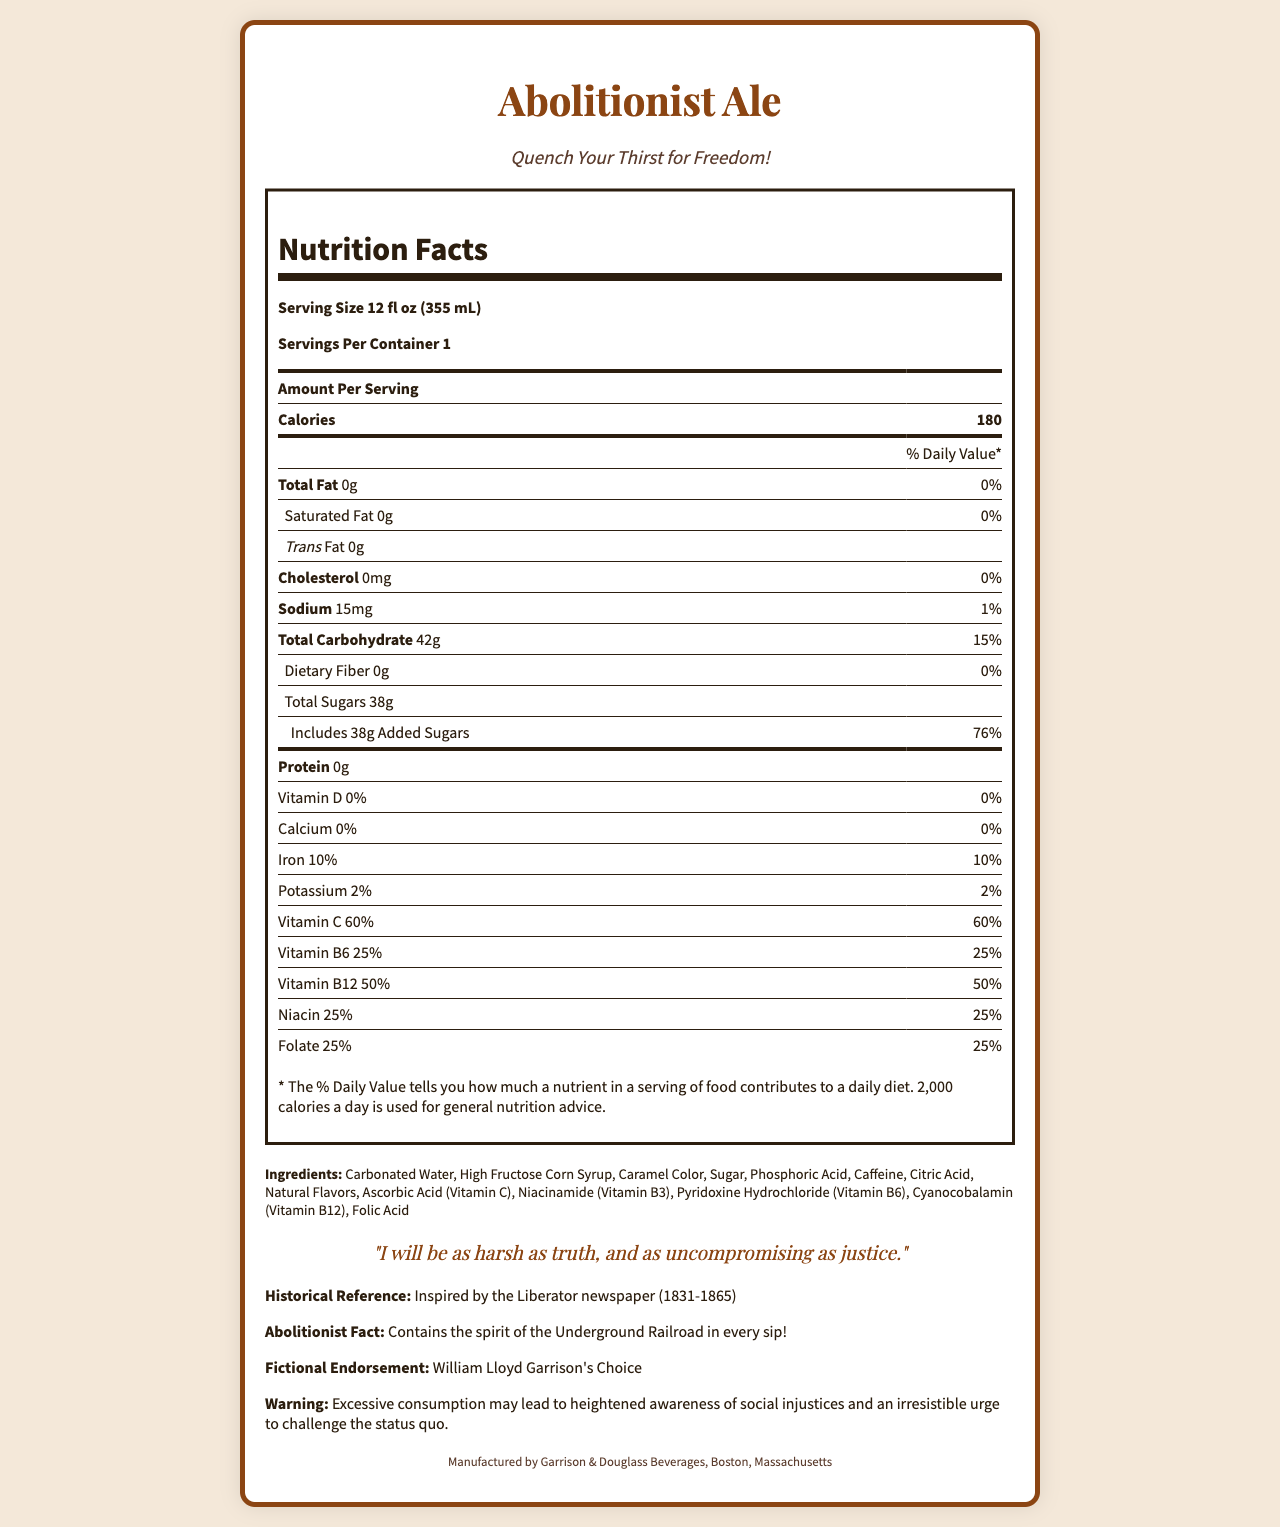what is the serving size of Abolitionist Ale? The serving size is stated as "Serving Size 12 fl oz (355 mL)" in the Nutrition Facts section.
Answer: 12 fl oz (355 mL) how many calories does Abolitionist Ale contain per serving? The number of calories per serving is indicated as "Calories 180" in the Nutrition Facts section.
Answer: 180 how much vitamin C does Abolitionist Ale provide per serving? The amount of Vitamin C per serving is shown as "Vitamin C 60%" in the Nutrition Facts section.
Answer: 60% what is the historical reference of Abolitionist Ale? The Historical Reference section states this information.
Answer: Inspired by the Liberator newspaper (1831-1865) what is the total carbohydrate content per serving? The total carbohydrate content is listed as "Total Carbohydrate 42g" in the Nutrition Facts section.
Answer: 42g how much sodium is in Abolitionist Ale? The sodium content per serving is specified as "Sodium 15mg" in the Nutrition Facts section.
Answer: 15mg which vitamin has the highest percentage Daily Value in Abolitionist Ale? 
A. Vitamin A 
B. Vitamin C 
C. Vitamin B12 
D. Niacin 
E. Folate According to the Nutrition Facts section, Vitamin C has the highest percentage Daily Value at 60%.
Answer: B what is the warning associated with Abolitionist Ale? 
I. May cause drowsiness 
II. Excessive consumption may lead to heightened awareness of social injustices 
III. Contains nuts The warning states that "Excessive consumption may lead to heightened awareness of social injustices and an irresistible urge to challenge the status quo."
Answer: II does Abolitionist Ale contain any saturated fat? The Nutrition Facts section shows "Saturated Fat 0g," indicating there is no saturated fat in the beverage.
Answer: No who endorses Abolitionist Ale fictional? The Fictional Endorsement section mentions "William Lloyd Garrison's Choice."
Answer: William Lloyd Garrison summarize the main nutritional features of Abolitionist Ale The summary provides an overall look at the main nutritional components, high sugar content, and vitamin fortifications.
Answer: Abolitionist Ale is a political-themed beverage with 180 calories per serving and a high sugar content of 38g. It is fortified with vitamins such as Vitamin C (60%), Vitamin B6 (25%), Vitamin B12 (50%), and others. The soda contains no fat, protein, or dietary fiber and has minimal amounts of sodium and potassium. how was the document generated? The document does not provide details on how it was generated; it only includes the visual and nutritional information.
Answer: Cannot be determined what is the revolutionary quote associated with Abolitionist Ale? The quote provided under the Quote section states: "I will be as harsh as truth, and as uncompromising as justice."
Answer: I will be as harsh as truth, and as uncompromising as justice. what percentage of the Daily Value is contributed by the added sugars in one serving of Abolitionist Ale? The Nutrition Facts indicate "Includes 38g Added Sugars" which contributes "76%" of the Daily Value.
Answer: 76% who manufactures Abolitionist Ale? The document states that the manufacturer is "Garrison & Douglass Beverages, Boston, Massachusetts."
Answer: Garrison & Douglass Beverages, Boston, Massachusetts 